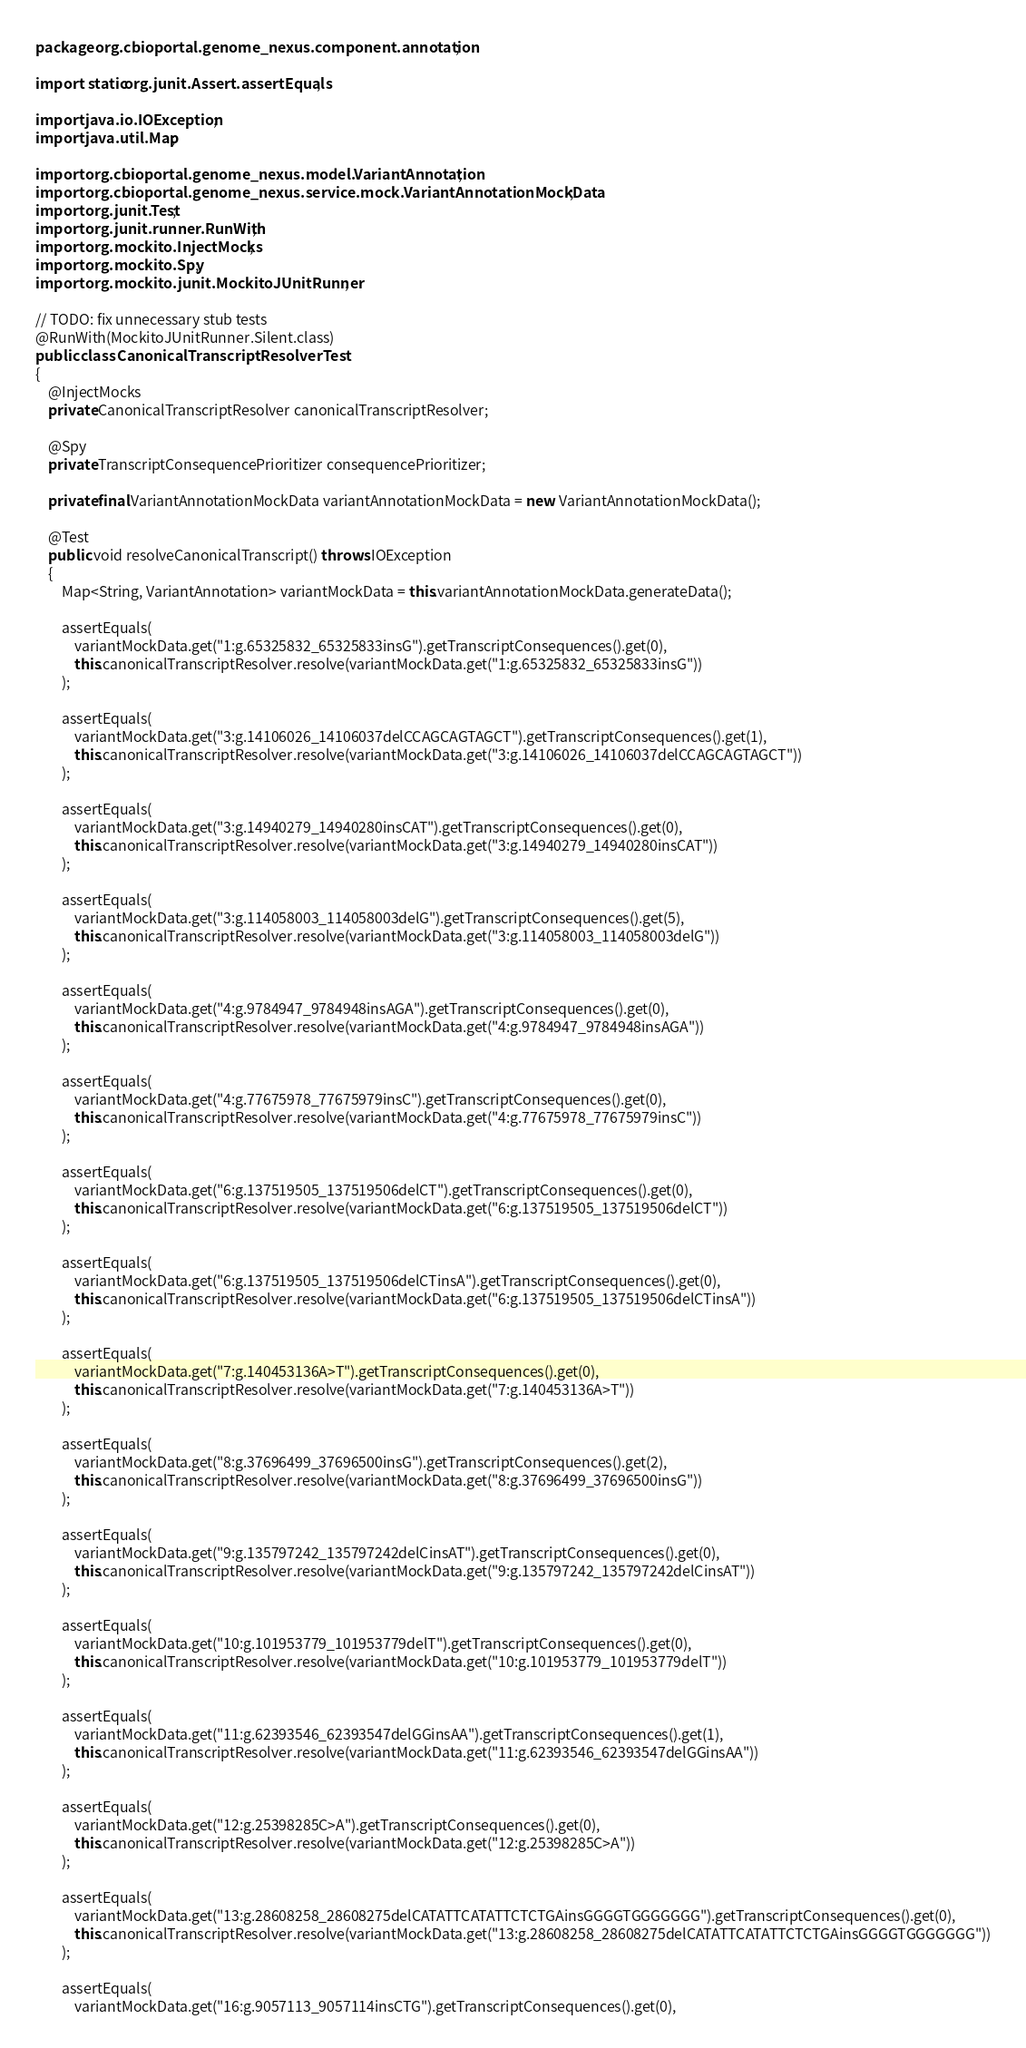Convert code to text. <code><loc_0><loc_0><loc_500><loc_500><_Java_>package org.cbioportal.genome_nexus.component.annotation;

import static org.junit.Assert.assertEquals;

import java.io.IOException;
import java.util.Map;

import org.cbioportal.genome_nexus.model.VariantAnnotation;
import org.cbioportal.genome_nexus.service.mock.VariantAnnotationMockData;
import org.junit.Test;
import org.junit.runner.RunWith;
import org.mockito.InjectMocks;
import org.mockito.Spy;
import org.mockito.junit.MockitoJUnitRunner;

// TODO: fix unnecessary stub tests 
@RunWith(MockitoJUnitRunner.Silent.class)
public class CanonicalTranscriptResolverTest
{
    @InjectMocks
    private CanonicalTranscriptResolver canonicalTranscriptResolver;

    @Spy
    private TranscriptConsequencePrioritizer consequencePrioritizer;

    private final VariantAnnotationMockData variantAnnotationMockData = new VariantAnnotationMockData();

    @Test
    public void resolveCanonicalTranscript() throws IOException
    {
        Map<String, VariantAnnotation> variantMockData = this.variantAnnotationMockData.generateData();

        assertEquals(
            variantMockData.get("1:g.65325832_65325833insG").getTranscriptConsequences().get(0),
            this.canonicalTranscriptResolver.resolve(variantMockData.get("1:g.65325832_65325833insG"))
        );

        assertEquals(
            variantMockData.get("3:g.14106026_14106037delCCAGCAGTAGCT").getTranscriptConsequences().get(1),
            this.canonicalTranscriptResolver.resolve(variantMockData.get("3:g.14106026_14106037delCCAGCAGTAGCT"))
        );

        assertEquals(
            variantMockData.get("3:g.14940279_14940280insCAT").getTranscriptConsequences().get(0),
            this.canonicalTranscriptResolver.resolve(variantMockData.get("3:g.14940279_14940280insCAT"))
        );

        assertEquals(
            variantMockData.get("3:g.114058003_114058003delG").getTranscriptConsequences().get(5),
            this.canonicalTranscriptResolver.resolve(variantMockData.get("3:g.114058003_114058003delG"))
        );

        assertEquals(
            variantMockData.get("4:g.9784947_9784948insAGA").getTranscriptConsequences().get(0),
            this.canonicalTranscriptResolver.resolve(variantMockData.get("4:g.9784947_9784948insAGA"))
        );

        assertEquals(
            variantMockData.get("4:g.77675978_77675979insC").getTranscriptConsequences().get(0),
            this.canonicalTranscriptResolver.resolve(variantMockData.get("4:g.77675978_77675979insC"))
        );

        assertEquals(
            variantMockData.get("6:g.137519505_137519506delCT").getTranscriptConsequences().get(0),
            this.canonicalTranscriptResolver.resolve(variantMockData.get("6:g.137519505_137519506delCT"))
        );

        assertEquals(
            variantMockData.get("6:g.137519505_137519506delCTinsA").getTranscriptConsequences().get(0),
            this.canonicalTranscriptResolver.resolve(variantMockData.get("6:g.137519505_137519506delCTinsA"))
        );

        assertEquals(
            variantMockData.get("7:g.140453136A>T").getTranscriptConsequences().get(0),
            this.canonicalTranscriptResolver.resolve(variantMockData.get("7:g.140453136A>T"))
        );

        assertEquals(
            variantMockData.get("8:g.37696499_37696500insG").getTranscriptConsequences().get(2),
            this.canonicalTranscriptResolver.resolve(variantMockData.get("8:g.37696499_37696500insG"))
        );

        assertEquals(
            variantMockData.get("9:g.135797242_135797242delCinsAT").getTranscriptConsequences().get(0),
            this.canonicalTranscriptResolver.resolve(variantMockData.get("9:g.135797242_135797242delCinsAT"))
        );

        assertEquals(
            variantMockData.get("10:g.101953779_101953779delT").getTranscriptConsequences().get(0),
            this.canonicalTranscriptResolver.resolve(variantMockData.get("10:g.101953779_101953779delT"))
        );

        assertEquals(
            variantMockData.get("11:g.62393546_62393547delGGinsAA").getTranscriptConsequences().get(1),
            this.canonicalTranscriptResolver.resolve(variantMockData.get("11:g.62393546_62393547delGGinsAA"))
        );

        assertEquals(
            variantMockData.get("12:g.25398285C>A").getTranscriptConsequences().get(0),
            this.canonicalTranscriptResolver.resolve(variantMockData.get("12:g.25398285C>A"))
        );

        assertEquals(
            variantMockData.get("13:g.28608258_28608275delCATATTCATATTCTCTGAinsGGGGTGGGGGGG").getTranscriptConsequences().get(0),
            this.canonicalTranscriptResolver.resolve(variantMockData.get("13:g.28608258_28608275delCATATTCATATTCTCTGAinsGGGGTGGGGGGG"))
        );

        assertEquals(
            variantMockData.get("16:g.9057113_9057114insCTG").getTranscriptConsequences().get(0),</code> 